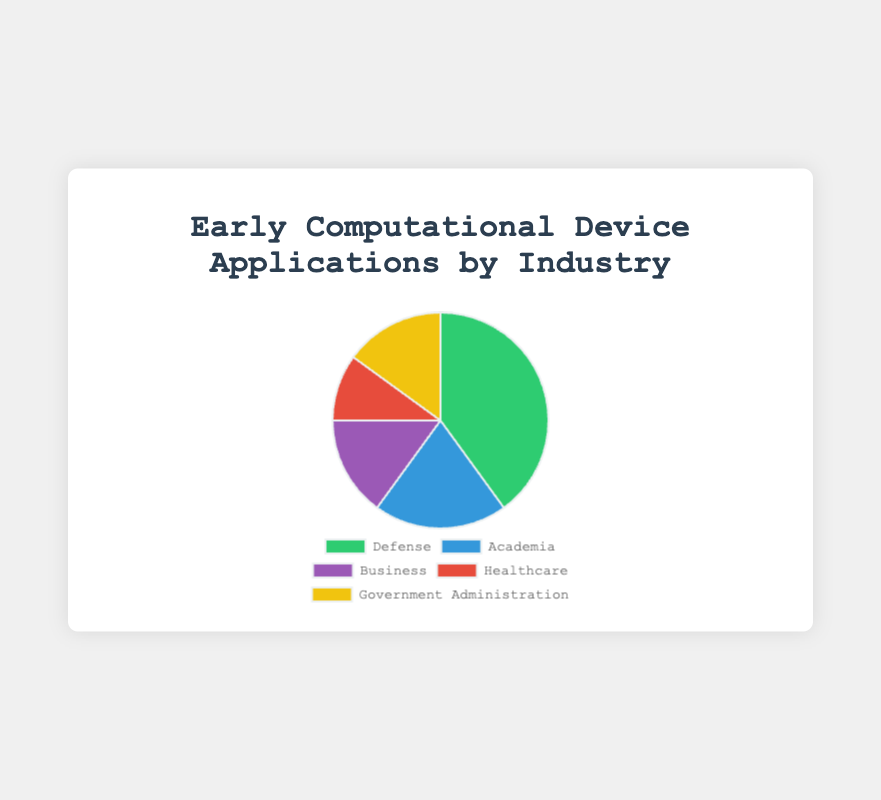What industry has the highest percentage of early computational device applications? By looking at the pie chart, the sector with the largest segment represents the industry with the highest percentage. Here, "Defense" has the largest segment at 40%.
Answer: Defense Compare the percentage of Business and Government Administration applications. Which industry has a higher percentage? Observe the segments corresponding to "Business" and "Government Administration". Both match in size and have a percentage label of 15%.
Answer: Equal What is the combined percentage of Healthcare and Academia applications? Sum the percentages of "Healthcare" (10%) and "Academia" (20%). The combined percentage is 10% + 20% = 30%.
Answer: 30% What is the difference in percentage between the Defense and Healthcare industries? Subtract the percentage of Healthcare (10%) from Defense (40%). The difference is 40% - 10% = 30%.
Answer: 30% What color represents the Academia industry in the pie chart? Refer to the color legend of the pie chart and identify the color labeled "Academia". In this case, "Academia" is represented by the color blue.
Answer: Blue Is the percentage of applications in Defense greater than the combined percentage of Business and Healthcare combined? Combine the percentages of Business (15%) and Healthcare (10%). The total is 15% + 10% = 25%. Since 40% (Defense) is greater than 25%, the statement is true.
Answer: Yes Which two industries have the same percentage of early computational device applications? By examining the pie chart, note that "Business" and "Government Administration" are both labeled with 15%.
Answer: Business and Government Administration What percentage of early computational device applications is not in Defense? Subtract Defense's percentage (40%) from the total (100%). The remaining percentage is 100% - 40% = 60%.
Answer: 60% How much larger is the percentage of Academia applications compared to Healthcare applications? Subtract Healthcare's percentage (10%) from Academia's (20%). The difference is 20% - 10% = 10%.
Answer: 10% What color is used to represent the Healthcare industry? Refer to the color legend of the pie chart and identify the color labeled "Healthcare". The Healthcare segment is represented by the color red.
Answer: Red 